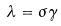Convert formula to latex. <formula><loc_0><loc_0><loc_500><loc_500>\lambda = \sigma \gamma</formula> 